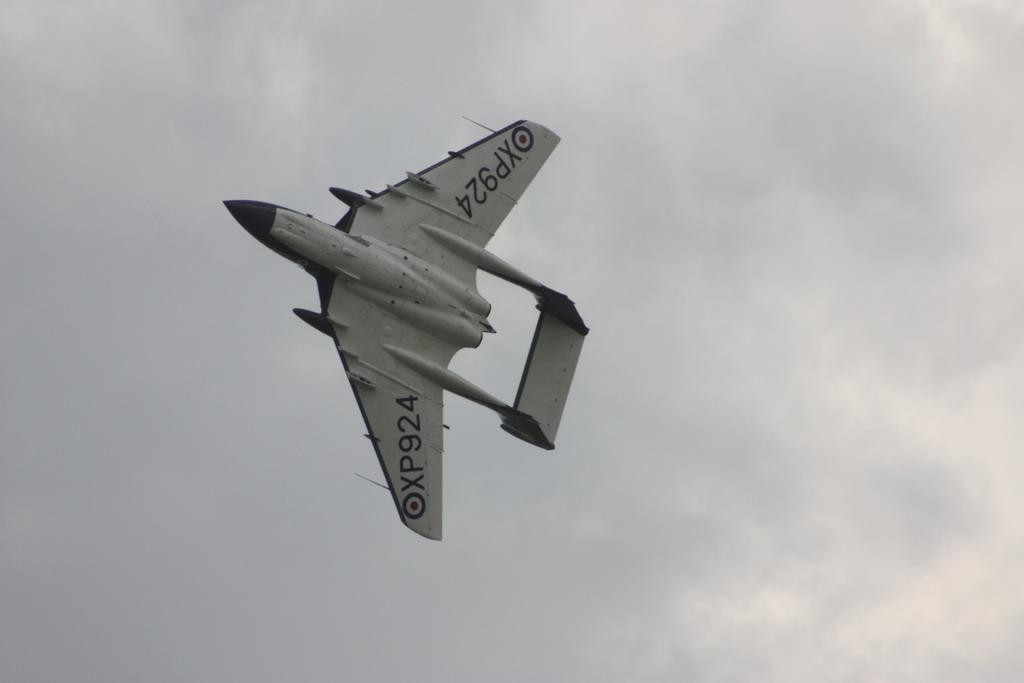What is the main subject of the image? The main subject of the image is an airplane. Can you describe the position of the airplane in the image? The airplane is in the air. How would you describe the weather based on the image? The sky is cloudy in the image. What religious symbols can be seen on the airplane in the image? There are no religious symbols visible on the airplane in the image. What type of produce is being transported by the airplane in the image? There is no produce visible in the image, and the purpose of the airplane is not indicated. 